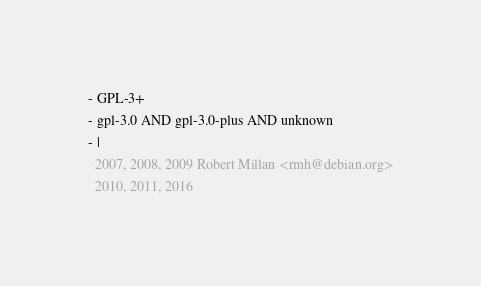Convert code to text. <code><loc_0><loc_0><loc_500><loc_500><_YAML_>- GPL-3+
- gpl-3.0 AND gpl-3.0-plus AND unknown
- |
  2007, 2008, 2009 Robert Millan <rmh@debian.org>
  2010, 2011, 2016
</code> 